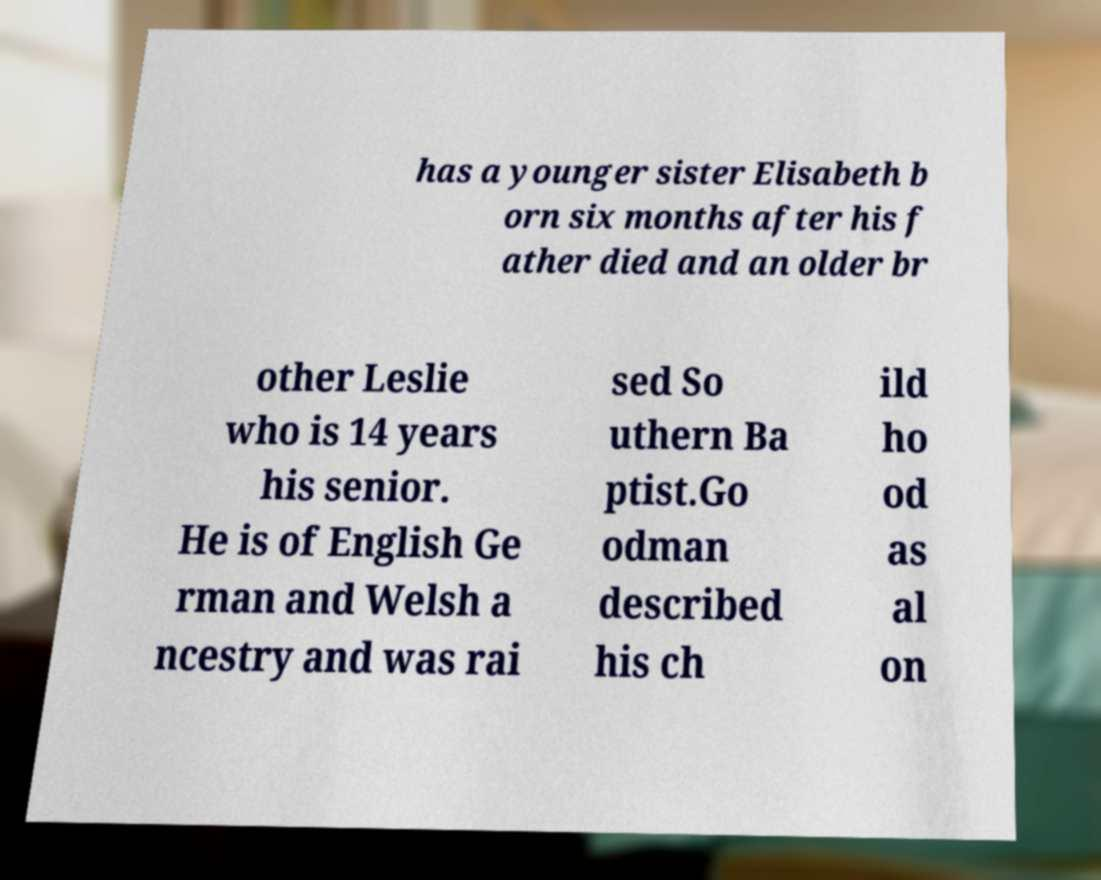Please identify and transcribe the text found in this image. has a younger sister Elisabeth b orn six months after his f ather died and an older br other Leslie who is 14 years his senior. He is of English Ge rman and Welsh a ncestry and was rai sed So uthern Ba ptist.Go odman described his ch ild ho od as al on 